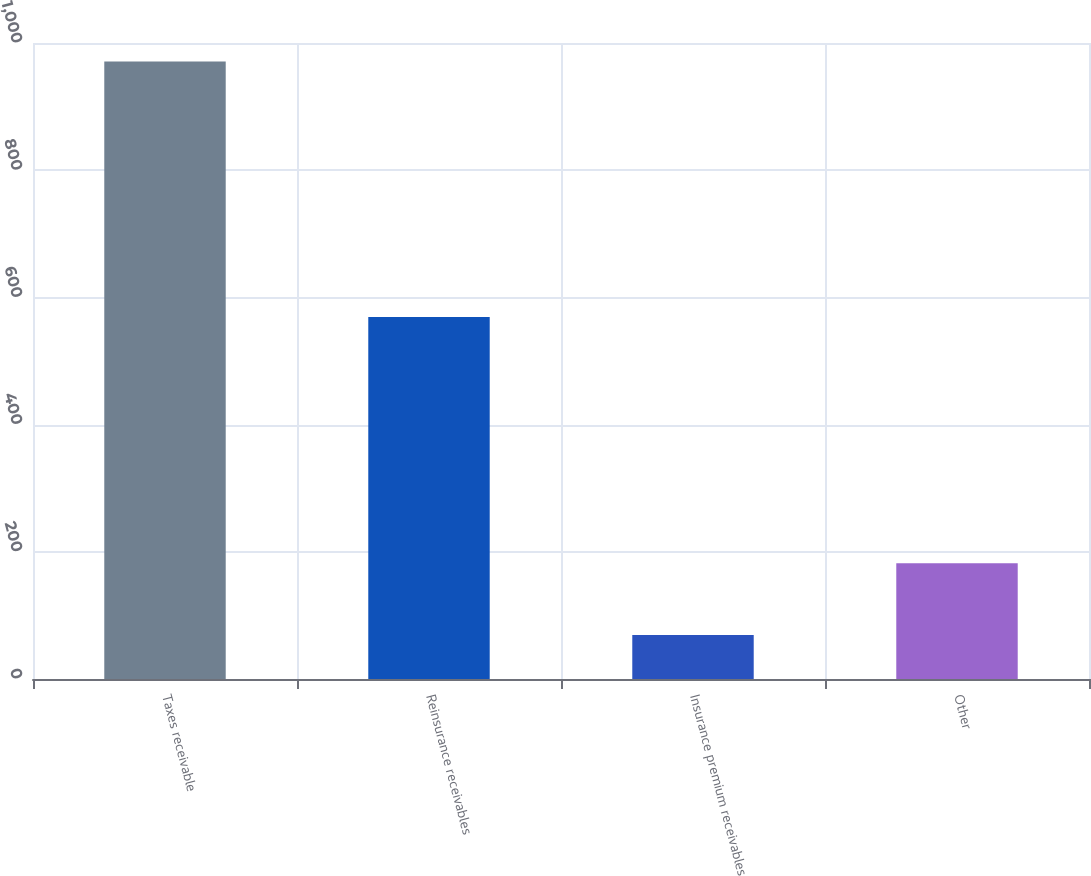Convert chart to OTSL. <chart><loc_0><loc_0><loc_500><loc_500><bar_chart><fcel>Taxes receivable<fcel>Reinsurance receivables<fcel>Insurance premium receivables<fcel>Other<nl><fcel>971<fcel>569<fcel>69<fcel>182<nl></chart> 